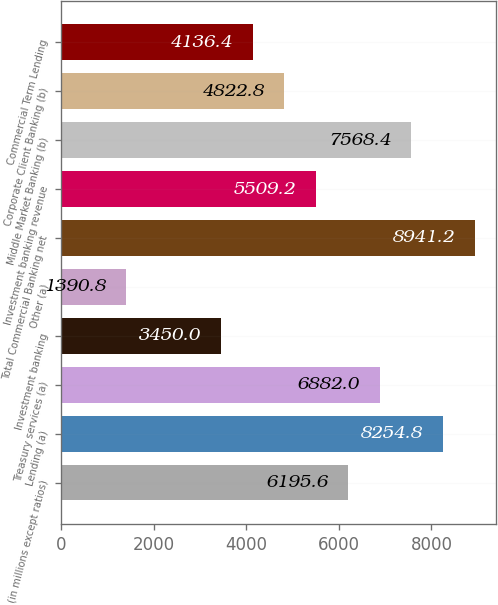Convert chart to OTSL. <chart><loc_0><loc_0><loc_500><loc_500><bar_chart><fcel>(in millions except ratios)<fcel>Lending (a)<fcel>Treasury services (a)<fcel>Investment banking<fcel>Other (a)<fcel>Total Commercial Banking net<fcel>Investment banking revenue<fcel>Middle Market Banking (b)<fcel>Corporate Client Banking (b)<fcel>Commercial Term Lending<nl><fcel>6195.6<fcel>8254.8<fcel>6882<fcel>3450<fcel>1390.8<fcel>8941.2<fcel>5509.2<fcel>7568.4<fcel>4822.8<fcel>4136.4<nl></chart> 